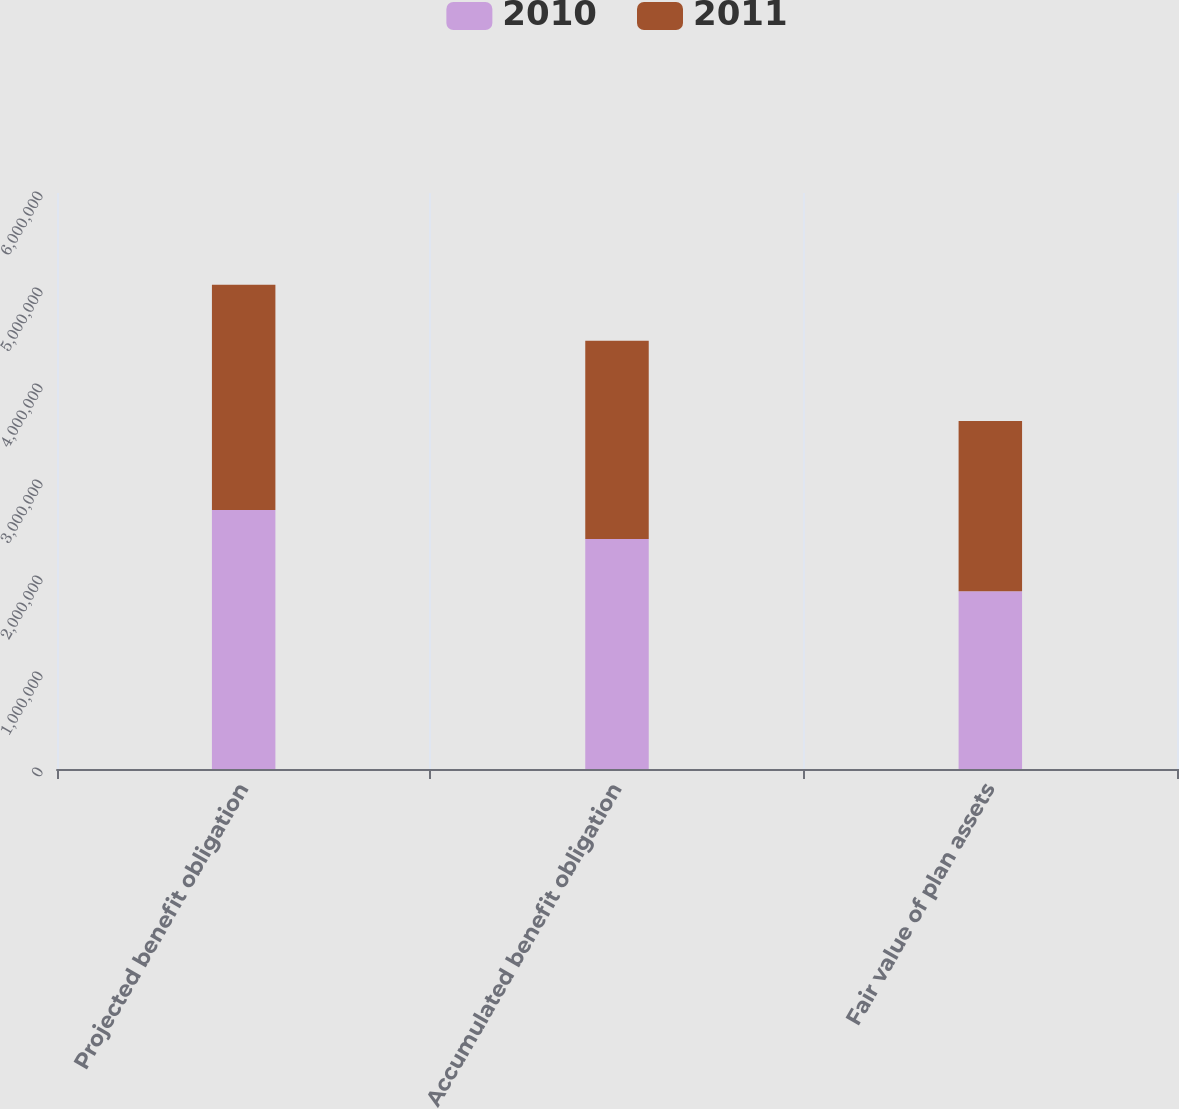<chart> <loc_0><loc_0><loc_500><loc_500><stacked_bar_chart><ecel><fcel>Projected benefit obligation<fcel>Accumulated benefit obligation<fcel>Fair value of plan assets<nl><fcel>2010<fcel>2.69913e+06<fcel>2.39658e+06<fcel>1.85055e+06<nl><fcel>2011<fcel>2.34506e+06<fcel>2.06509e+06<fcel>1.7756e+06<nl></chart> 